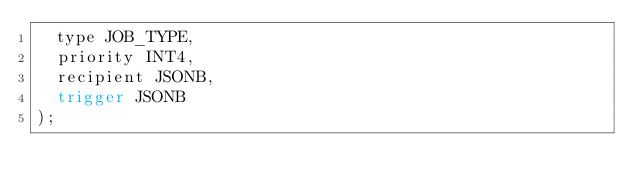Convert code to text. <code><loc_0><loc_0><loc_500><loc_500><_SQL_>  type JOB_TYPE,
  priority INT4,
  recipient JSONB,
  trigger JSONB
);
</code> 